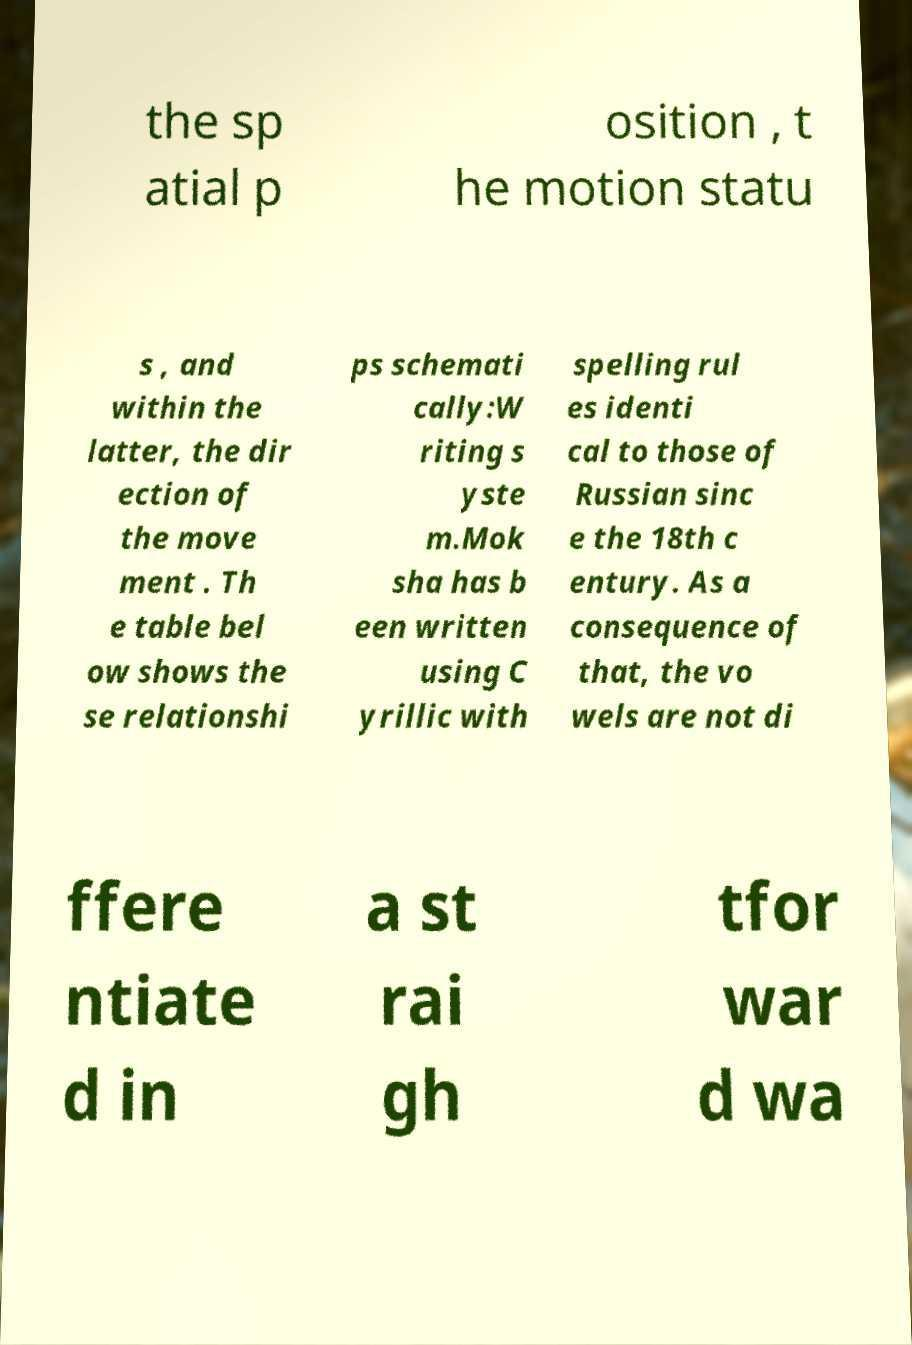There's text embedded in this image that I need extracted. Can you transcribe it verbatim? the sp atial p osition , t he motion statu s , and within the latter, the dir ection of the move ment . Th e table bel ow shows the se relationshi ps schemati cally:W riting s yste m.Mok sha has b een written using C yrillic with spelling rul es identi cal to those of Russian sinc e the 18th c entury. As a consequence of that, the vo wels are not di ffere ntiate d in a st rai gh tfor war d wa 